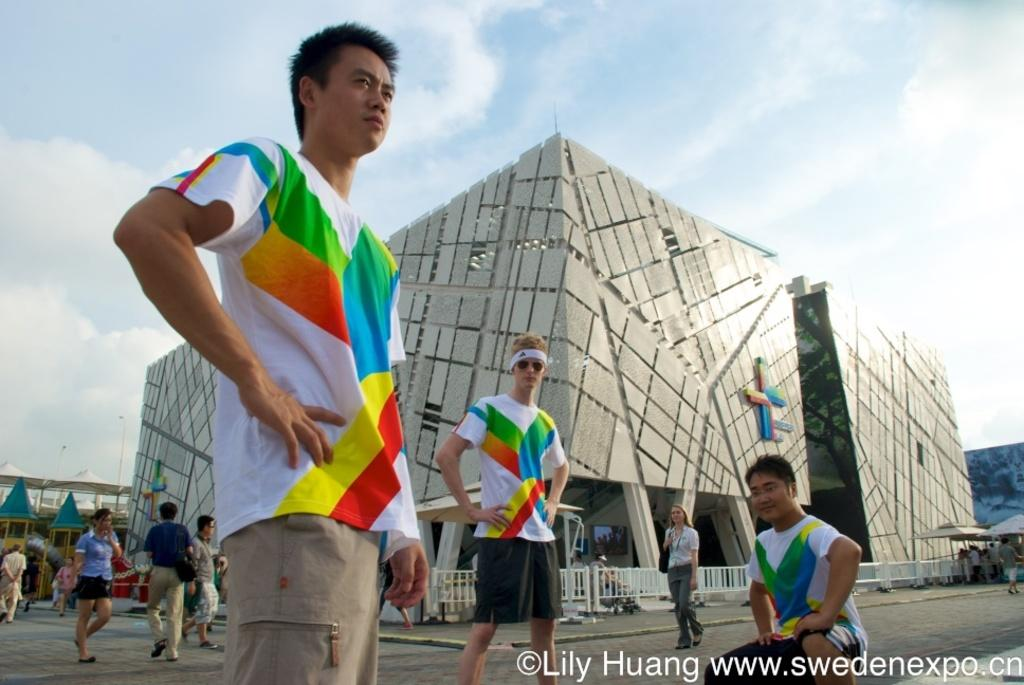What type of structures can be seen in the image? There are buildings in the image. Who or what else is present in the image? There are people in the image. What separates the buildings from the surrounding area? There is a fence in the image. What can be seen in the distance in the image? The sky is visible in the background of the image. What time of day is it in the image, and who made the request for afternoon tea? The time of day cannot be determined from the image, and there is no mention of a request for afternoon tea. 